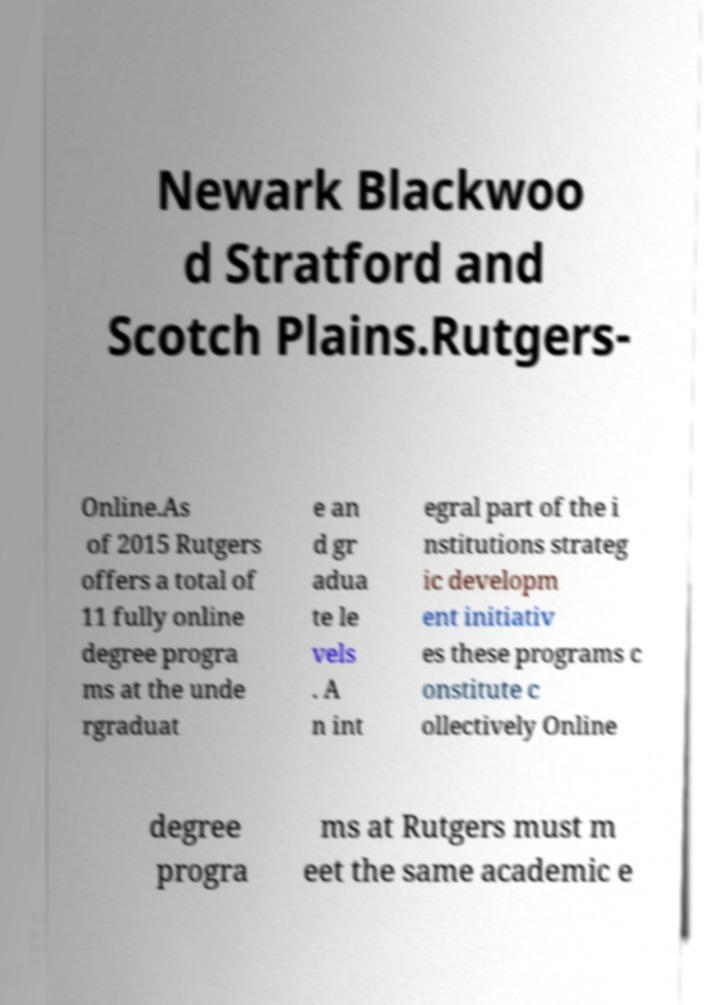Could you extract and type out the text from this image? Newark Blackwoo d Stratford and Scotch Plains.Rutgers- Online.As of 2015 Rutgers offers a total of 11 fully online degree progra ms at the unde rgraduat e an d gr adua te le vels . A n int egral part of the i nstitutions strateg ic developm ent initiativ es these programs c onstitute c ollectively Online degree progra ms at Rutgers must m eet the same academic e 